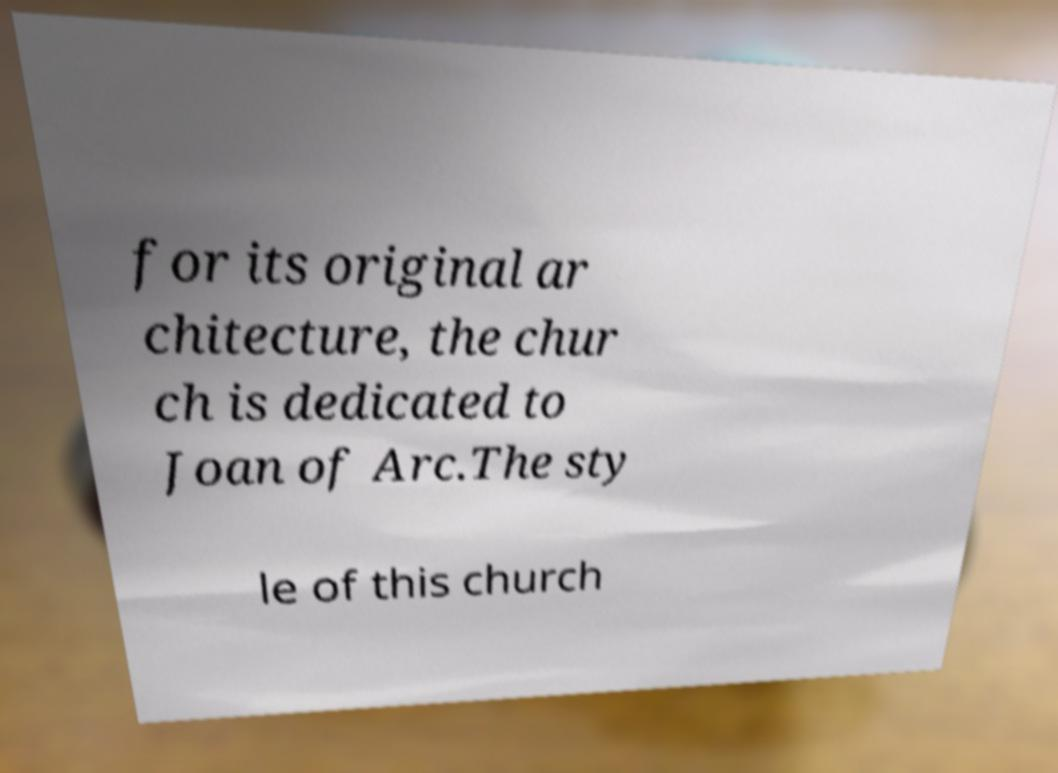For documentation purposes, I need the text within this image transcribed. Could you provide that? for its original ar chitecture, the chur ch is dedicated to Joan of Arc.The sty le of this church 